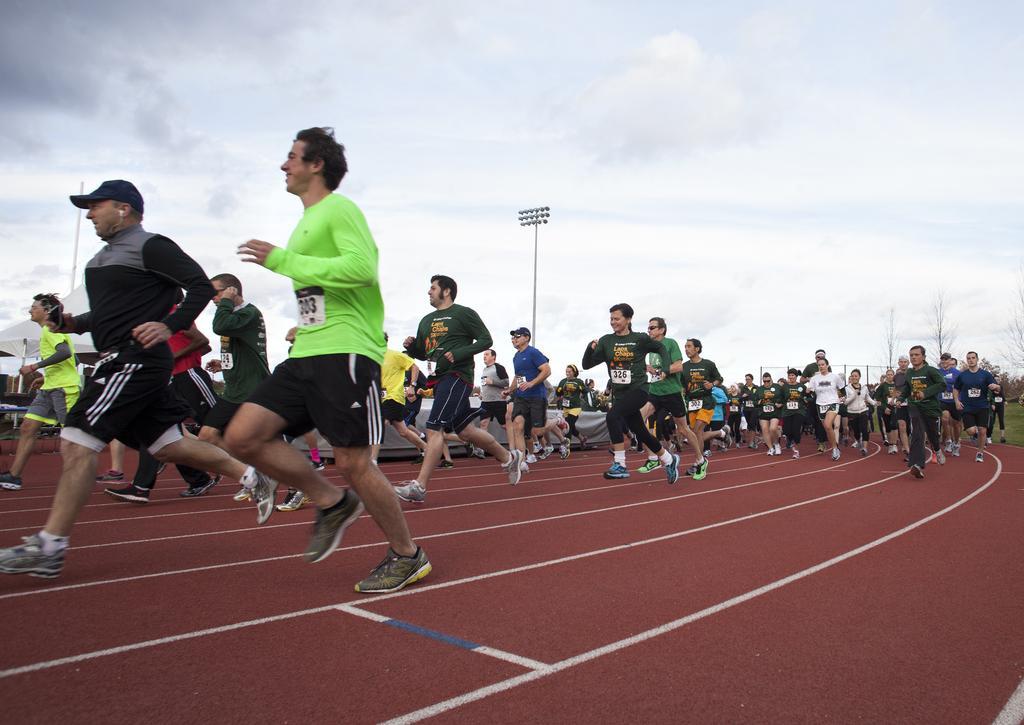Describe this image in one or two sentences. In this image, there are a few people. We can see the ground and a white colored object. We can see some poles and trees. We can also see the sky with clouds. We can also see a tent and some grass. 